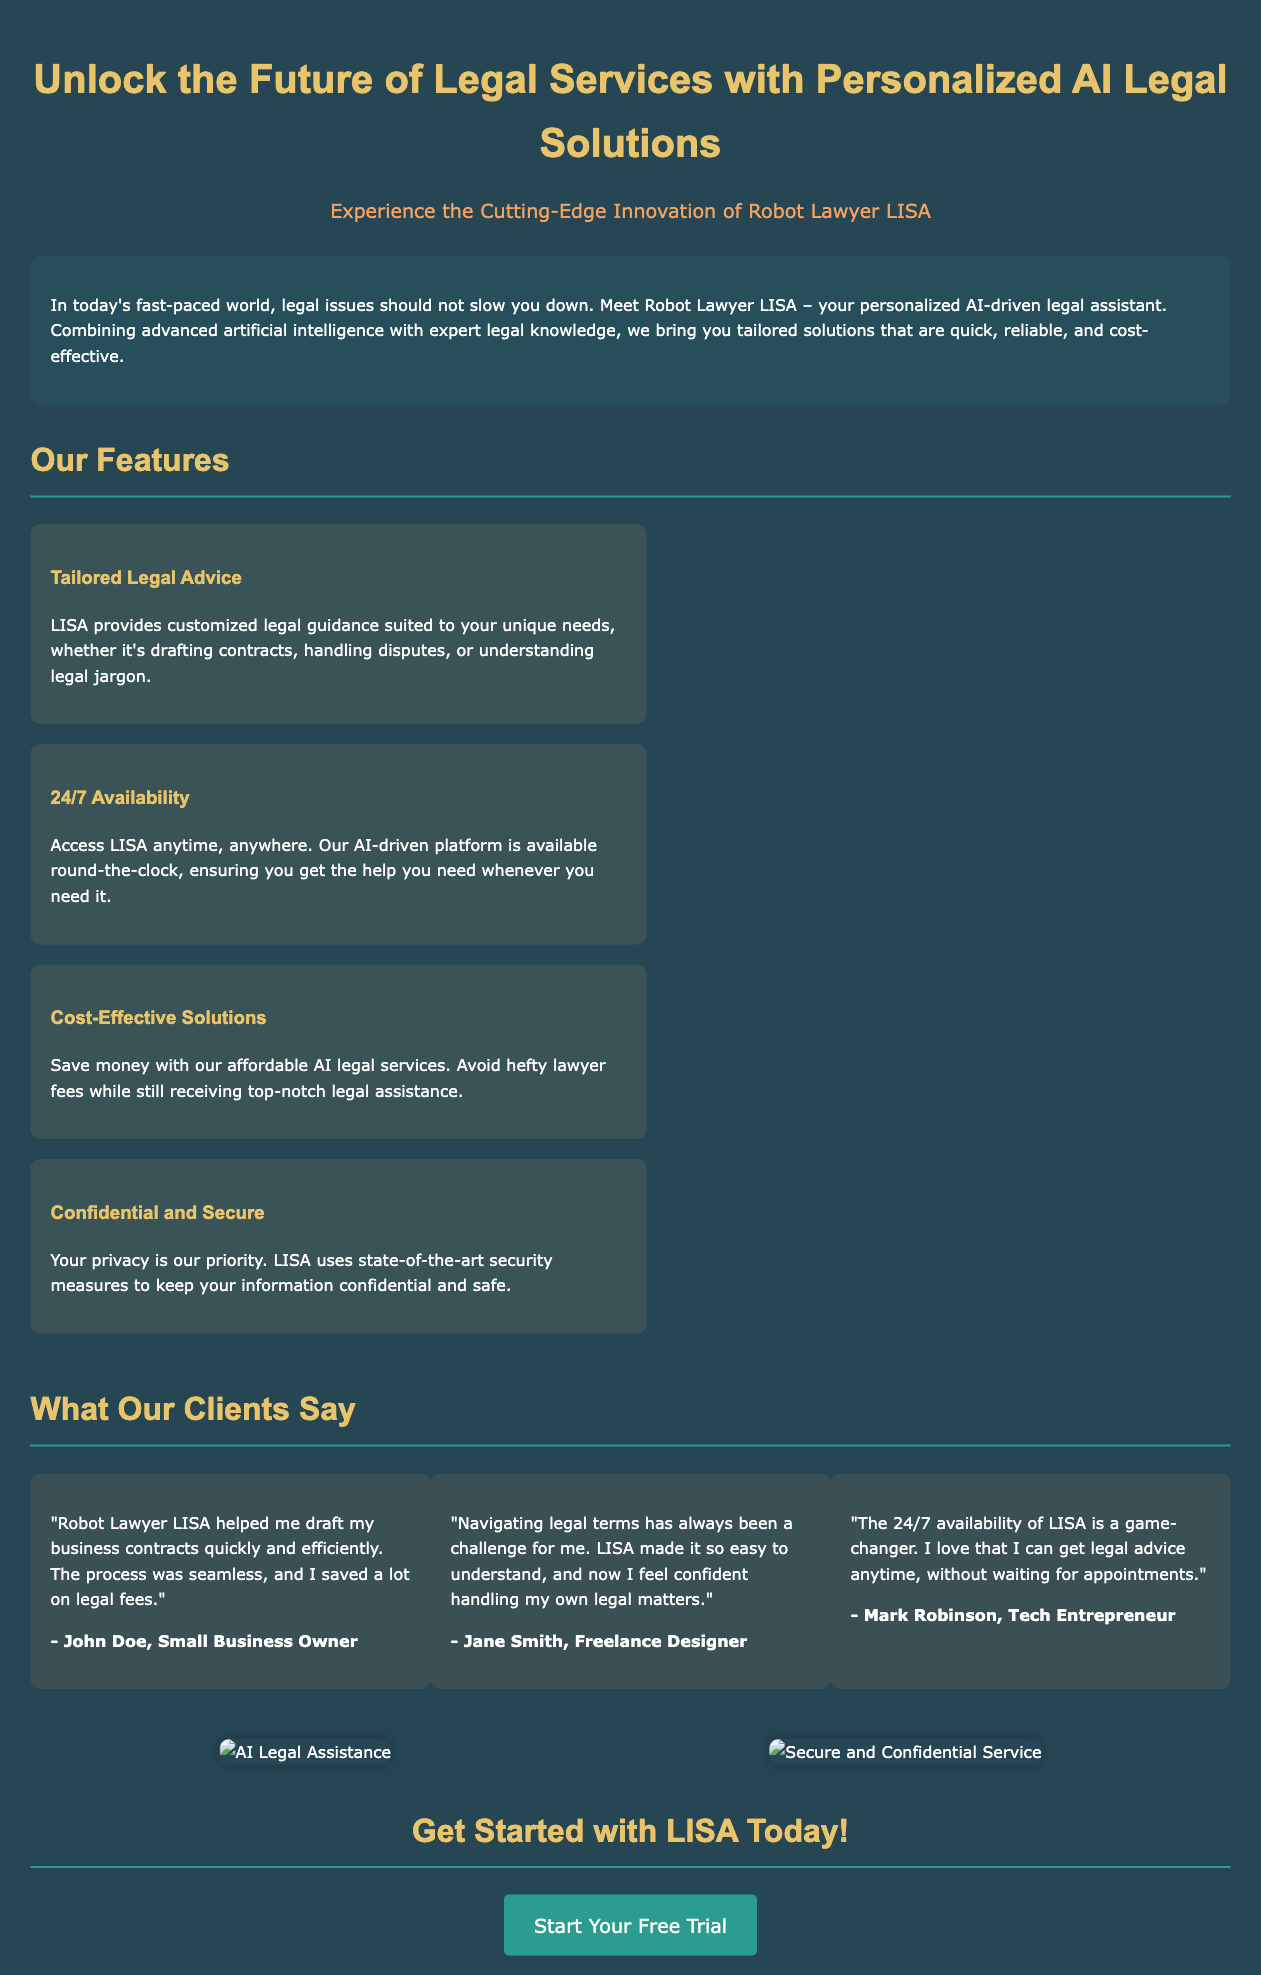What is the name of the AI legal assistant? The document introduces the personalized AI legal assistant as Robot Lawyer LISA.
Answer: Robot Lawyer LISA What color is used for the background? The background color of the document is specified as #264653.
Answer: #264653 How many client testimonials are included? The document lists three client testimonials under the testimonials section.
Answer: Three What feature emphasizes cost savings? The document mentions "Cost-Effective Solutions" as a key feature highlighting affordability.
Answer: Cost-Effective Solutions What is the call-to-action in the advertisement? The call-to-action encourages users to start a free trial of the service from the document.
Answer: Start Your Free Trial What type of services does LISA provide? The advertisement describes the services offered by LISA as legal assistance and tailored legal advice.
Answer: Legal assistance Which testimonial mentions 24/7 availability? The testimonial from Mark Robinson specifically praises the 24/7 availability of LISA for legal advice.
Answer: Mark Robinson What is a highlighted benefit regarding privacy? The document states that LISA uses "state-of-the-art security measures" to protect user information.
Answer: State-of-the-art security measures In what format are client testimonials presented? The client testimonials are presented in a paragraph format, including the quote and the speaker's name.
Answer: Paragraph format 